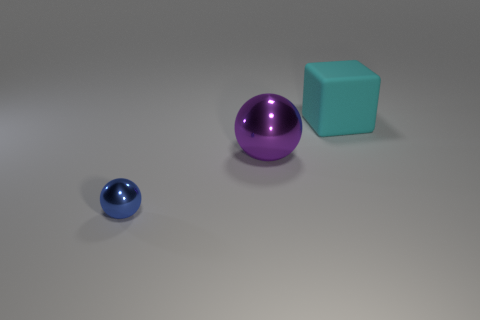Add 1 big green cylinders. How many objects exist? 4 Subtract all purple spheres. How many spheres are left? 1 Subtract 0 brown cubes. How many objects are left? 3 Subtract all balls. How many objects are left? 1 Subtract 1 blocks. How many blocks are left? 0 Subtract all blue cubes. Subtract all green balls. How many cubes are left? 1 Subtract all green spheres. How many blue blocks are left? 0 Subtract all small brown matte things. Subtract all large shiny things. How many objects are left? 2 Add 2 blue shiny spheres. How many blue shiny spheres are left? 3 Add 2 small brown rubber things. How many small brown rubber things exist? 2 